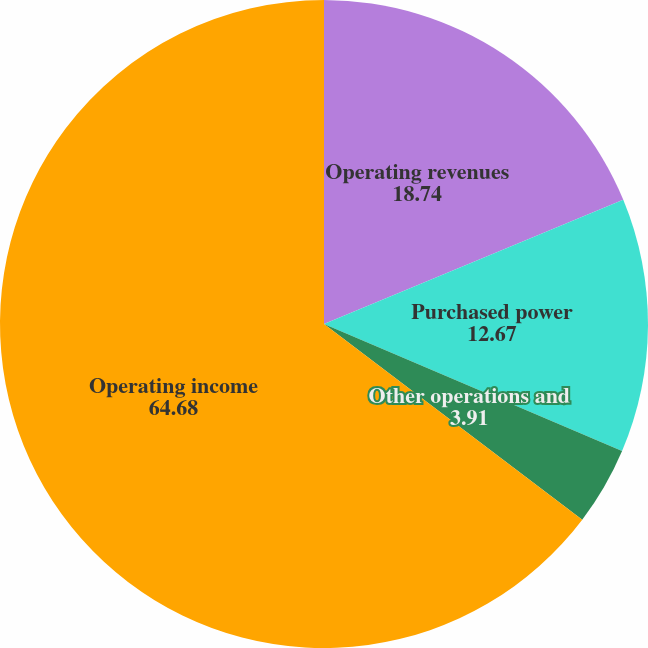<chart> <loc_0><loc_0><loc_500><loc_500><pie_chart><fcel>Operating revenues<fcel>Purchased power<fcel>Other operations and<fcel>Operating income<nl><fcel>18.74%<fcel>12.67%<fcel>3.91%<fcel>64.68%<nl></chart> 